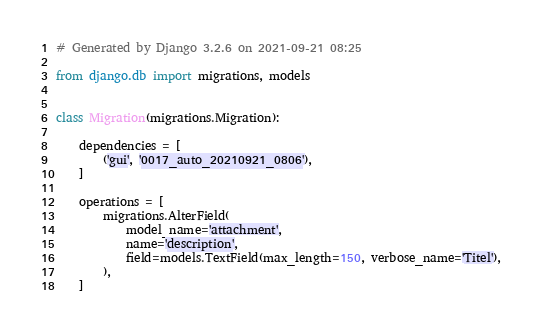<code> <loc_0><loc_0><loc_500><loc_500><_Python_># Generated by Django 3.2.6 on 2021-09-21 08:25

from django.db import migrations, models


class Migration(migrations.Migration):

    dependencies = [
        ('gui', '0017_auto_20210921_0806'),
    ]

    operations = [
        migrations.AlterField(
            model_name='attachment',
            name='description',
            field=models.TextField(max_length=150, verbose_name='Titel'),
        ),
    ]
</code> 